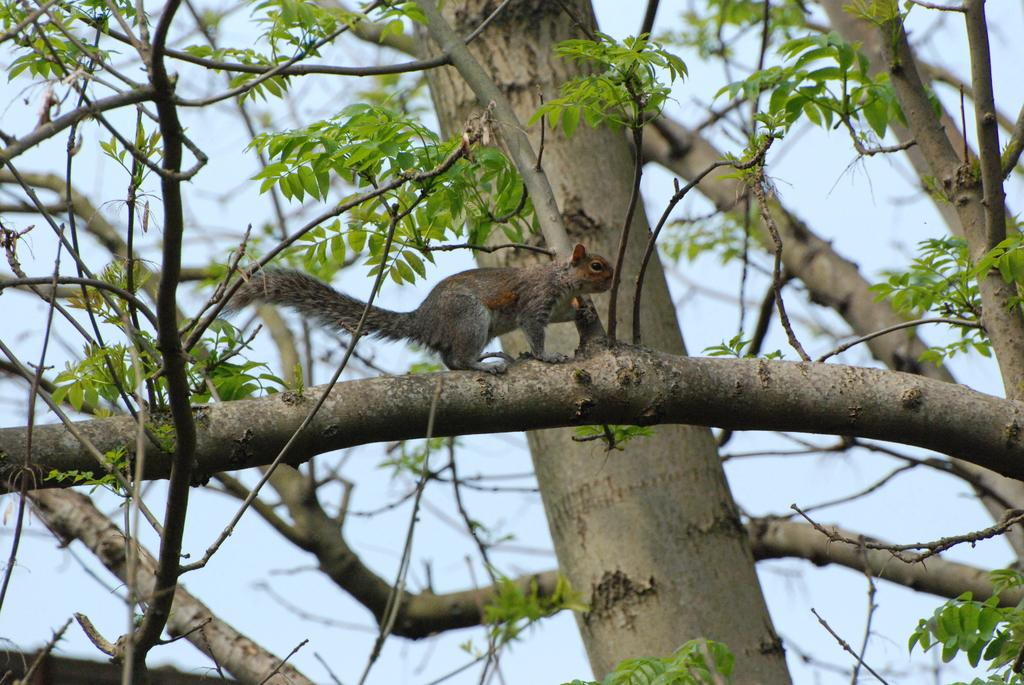What animal can be seen in the image? There is a squirrel in the image. Where is the squirrel located? The squirrel is on a branch. What is behind the squirrel? There is a tree behind the squirrel. What part of the natural environment is visible in the image? The sky is visible in the image. What is the weight of the root visible in the image? There is no root visible in the image; the focus is on the squirrel, the branch, the tree, and the sky. 